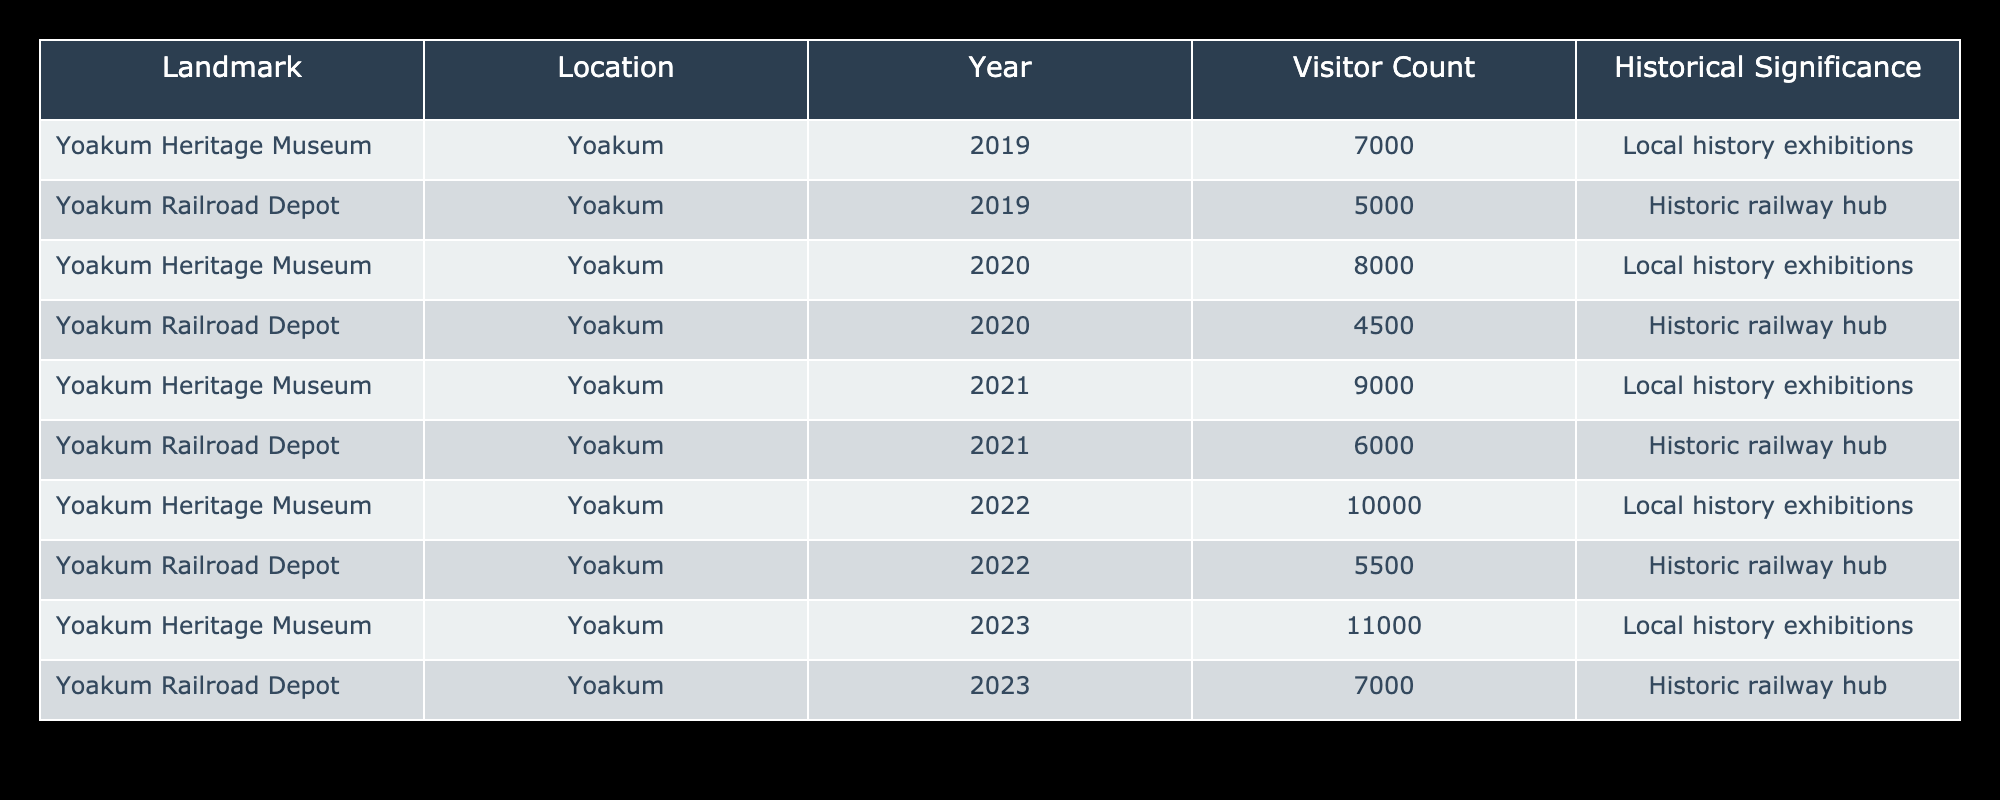What was the visitor count for the Yoakum Heritage Museum in 2020? Refer to the row for the Yoakum Heritage Museum in the year 2020, which shows a visitor count of 8000.
Answer: 8000 What is the total visitor count for the Yoakum Railroad Depot from 2019 to 2023? To find the total visitor count, add the visitor counts from each year: 5000 (2019) + 4500 (2020) + 6000 (2021) + 5500 (2022) + 7000 (2023) = 28500.
Answer: 28500 Did the Yoakum Heritage Museum have a higher visitor count than the Yoakum Railroad Depot in 2021? In 2021, the Yoakum Heritage Museum had 9000 visitors, while the Yoakum Railroad Depot had 6000 visitors. Since 9000 is greater than 6000, the answer is yes.
Answer: Yes What is the average visitor count for the Yoakum Heritage Museum over the five years? To calculate the average, sum the visitor counts for the Yoakum Heritage Museum: 7000 + 8000 + 9000 + 10000 + 11000 = 48000. Then, divide by the number of years (5): 48000 / 5 = 9600.
Answer: 9600 In which year did the Yoakum Railroad Depot experience its highest visitor count? Looking through the rows for the Yoakum Railroad Depot, the highest count is 7000, which occurred in the year 2023.
Answer: 2023 What was the difference in visitor count for the Yoakum Heritage Museum between 2019 and 2022? The visitor count for the Yoakum Heritage Museum in 2019 was 7000, and in 2022 it was 10000. The difference is 10000 - 7000 = 3000.
Answer: 3000 Did the visitor count for the Yoakum Railroad Depot decline from 2019 to 2020? The visitor count for 2019 was 5000, and for 2020 it was 4500. Since 4500 is less than 5000, this indicates a decline.
Answer: Yes Which landmark had the highest cumulative visitor count over the five years? Summing the visitor counts for each landmark: Yoakum Heritage Museum totals 48000 and Yoakum Railroad Depot totals 28500. 48000 is greater, indicating the Yoakum Heritage Museum had the highest cumulative count.
Answer: Yoakum Heritage Museum 